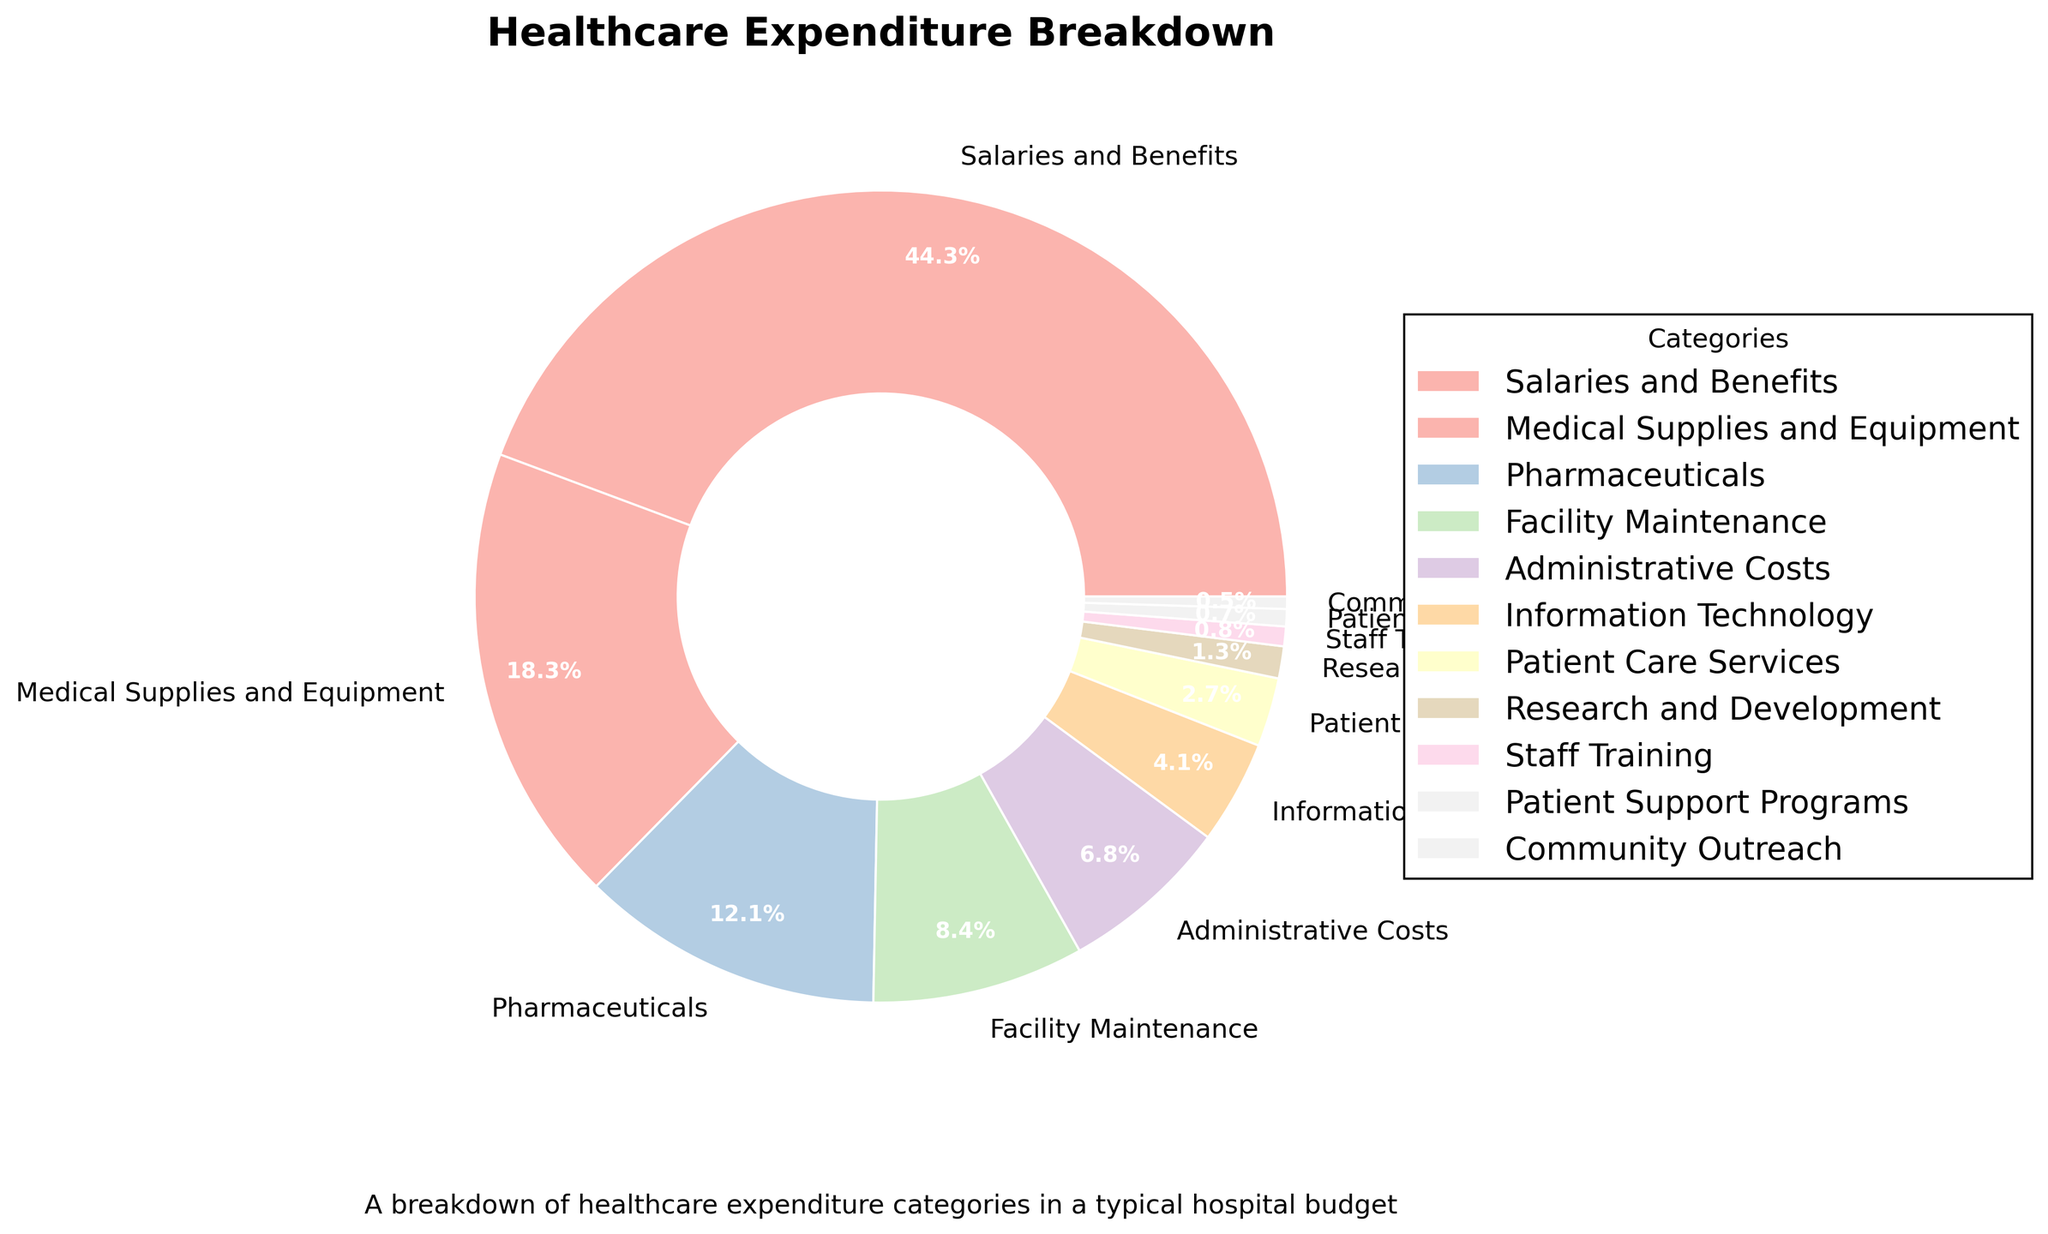What category has the highest percentage of expenditure? The pie chart shows the breakdown of healthcare expenditure by category, with the largest slice representing Salaries and Benefits. It occupies 45.2% of the chart.
Answer: Salaries and Benefits Which category has the second-highest expenditure? The second-largest portion of the pie chart, following Salaries and Benefits, is Medical Supplies and Equipment, which accounts for 18.7%.
Answer: Medical Supplies and Equipment How much more is spent on Medical Supplies and Equipment compared to Pharmaceuticals? To find the difference, subtract the percentage of Pharmaceuticals (12.3%) from Medical Supplies and Equipment (18.7%). The calculation is 18.7% - 12.3% = 6.4%.
Answer: 6.4% What is the combined percentage of expenditure on Administrative Costs, Information Technology, and Patient Care Services? Add the percentages for Administrative Costs (6.9%), Information Technology (4.2%), and Patient Care Services (2.8%). The calculation is 6.9% + 4.2% + 2.8% = 13.9%.
Answer: 13.9% Is the expenditure on Patient Support Programs higher or lower than that on Community Outreach? The percentages for Patient Support Programs and Community Outreach are 0.7% and 0.5%, respectively. Since 0.7% is greater than 0.5%, the expenditure is higher on Patient Support Programs.
Answer: Higher Which three categories have the lowest expenditure? By examining the smallest slices of the pie chart, the three categories with the lowest expenditure are Community Outreach (0.5%), Patient Support Programs (0.7%), and Staff Training (0.8%).
Answer: Community Outreach, Patient Support Programs, and Staff Training How does the expenditure on Facility Maintenance compare to that on Information Technology and Patient Care Services combined? Facility Maintenance is 8.6%. The combined expenditure for Information Technology (4.2%) and Patient Care Services (2.8%) is 4.2% + 2.8% = 7%. Since 8.6% > 7%, Facility Maintenance expenditure is higher.
Answer: Higher What is the percentage difference between Staff Training and Research and Development? Subtract the percentage of Staff Training (0.8%) from Research and Development (1.3%). The calculation is 1.3% - 0.8% = 0.5%.
Answer: 0.5% If you combined the expenditure on Pharmaceuticals and Medical Supplies and Equipment, what would be the total percentage? Does this combined value exceed the expenditure on Salaries and Benefits? Add the percentages for Pharmaceuticals (12.3%) and Medical Supplies and Equipment (18.7%), which gives 12.3% + 18.7% = 31%. This does not exceed Salaries and Benefits (45.2%).
Answer: 31%, No How many categories have a percentage expenditure less than 5%? The categories with expenditures less than 5% are Information Technology (4.2%), Patient Care Services (2.8%), Research and Development (1.3%), Staff Training (0.8%), Patient Support Programs (0.7%), and Community Outreach (0.5%). Count them to confirm: 6 categories.
Answer: 6 